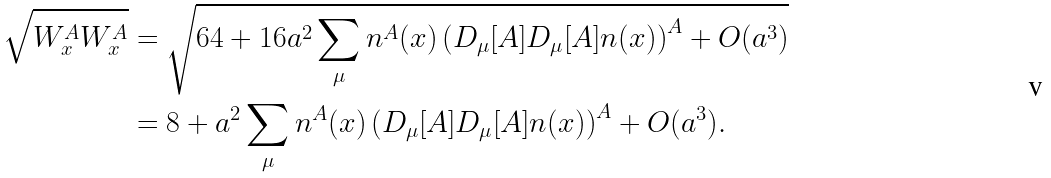<formula> <loc_0><loc_0><loc_500><loc_500>\sqrt { W ^ { A } _ { x } W ^ { A } _ { x } } & = \sqrt { 6 4 + 1 6 a ^ { 2 } \sum _ { \mu } n ^ { A } ( x ) \left ( D _ { \mu } [ { A } ] D _ { \mu } [ { A } ] { n } ( x ) \right ) ^ { A } + O ( a ^ { 3 } ) } \\ & = 8 + a ^ { 2 } \sum _ { \mu } n ^ { A } ( x ) \left ( D _ { \mu } [ { A } ] D _ { \mu } [ { A } ] { n } ( x ) \right ) ^ { A } + O ( a ^ { 3 } ) .</formula> 